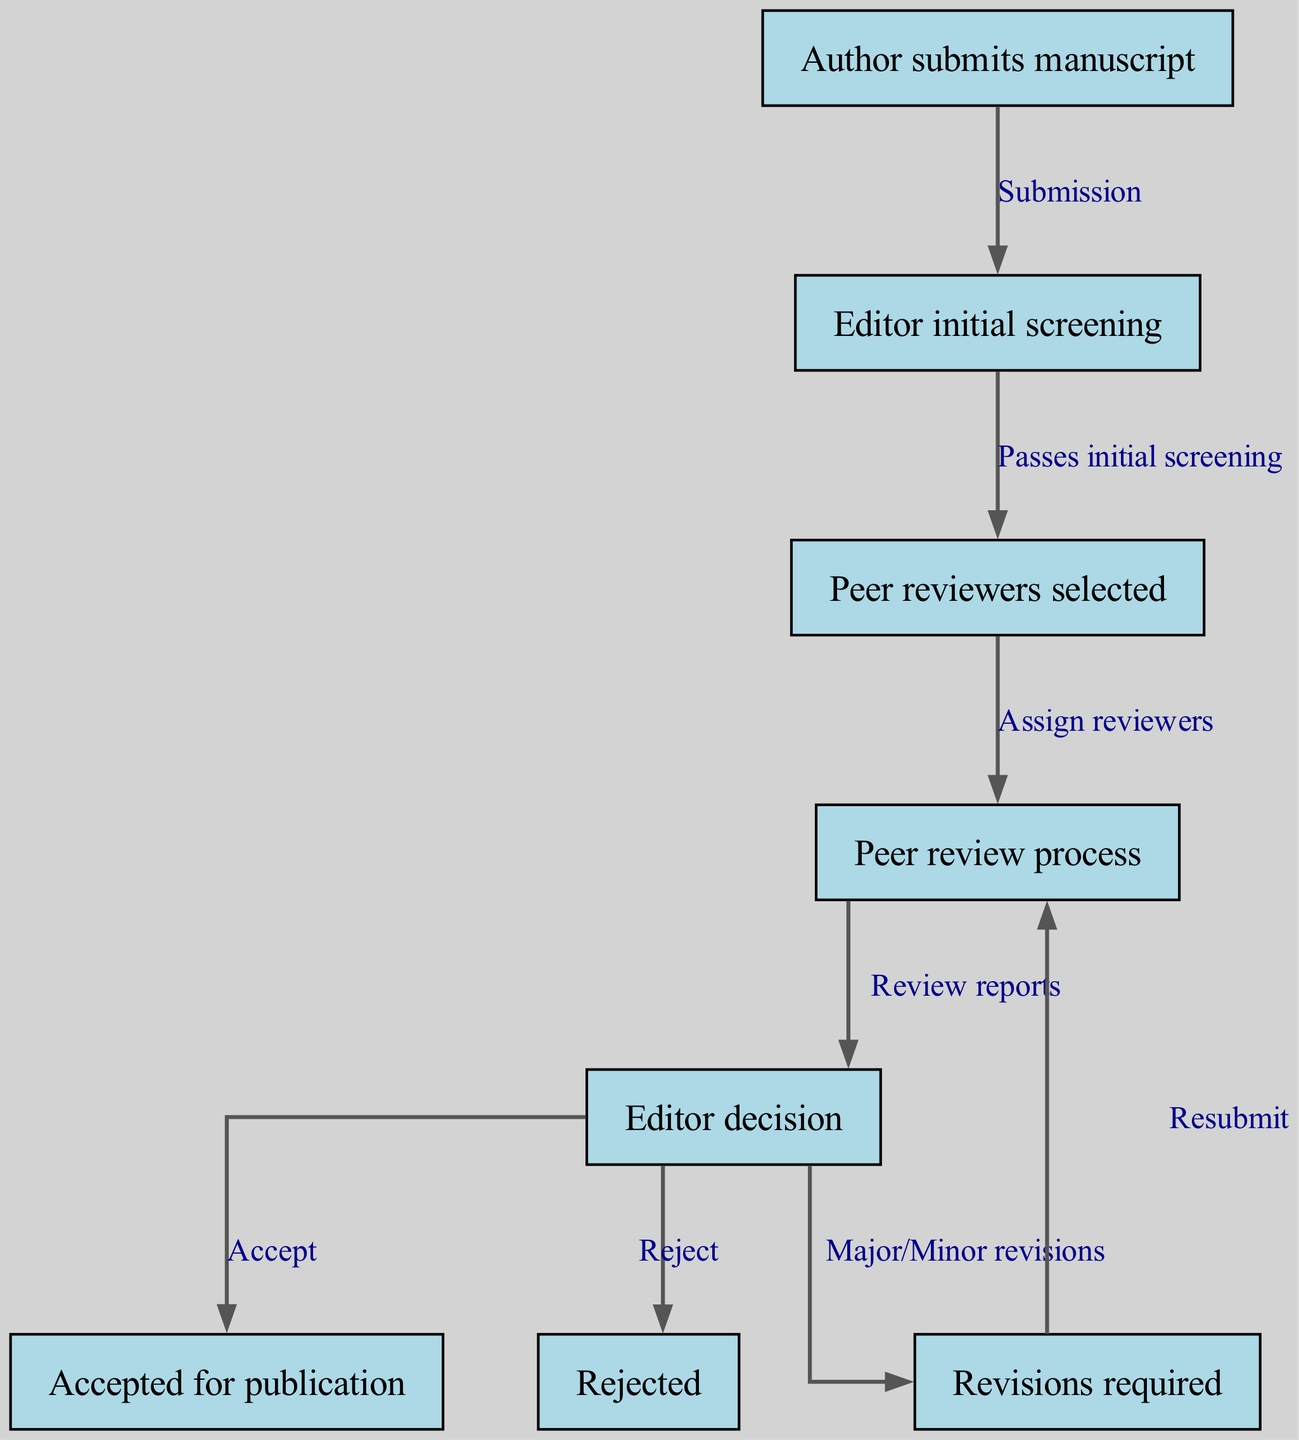What is the first step in the peer review process? The first step is the "Author submits manuscript" node, which indicates that the process begins with the author's submission of their work.
Answer: Author submits manuscript How many nodes are present in the diagram? Counting all the unique steps or states, there are eight nodes in the diagram, corresponding to the various stages of the peer review process.
Answer: 8 Which node follows "Editor decision" if revisions are required? If "Revisions required" is issued by the editor, the next node in the flow is "Peer review process," indicating that the manuscript needs to go through the review process again after revisions.
Answer: Peer review process What action occurs after the "Editor initial screening"? After the "Editor initial screening," the next action is to select "Peer reviewers," which is indicated by the directed edge that connects these two nodes.
Answer: Peer reviewers selected What are the three possible outcomes after the "Editor decision"? From the "Editor decision" node, there are three possible outcomes: "Accepted for publication," "Rejected," and "Revisions required," making these the potential paths stemming from the decision.
Answer: Accepted for publication, Rejected, Revisions required How does a manuscript return to the peer review process after revisions? When revisions are required, the author is expected to "Resubmit" the manuscript. This action points back to the "Peer review process," thus re-entering that stage after revisions are implemented.
Answer: Resubmit What label describes the relationship between "Peer reviewers selected" and "Peer review process"? The relationship between these two nodes is described by the label "Assign reviewers," indicating that selecting reviewers is a precursor to initiating the review process.
Answer: Assign reviewers How is the peer review process initiated? The peer review process is initiated when the "Peer reviewers selected" node is connected to the "Peer review process" node by the edge labeled "Assign reviewers."
Answer: Assign reviewers 